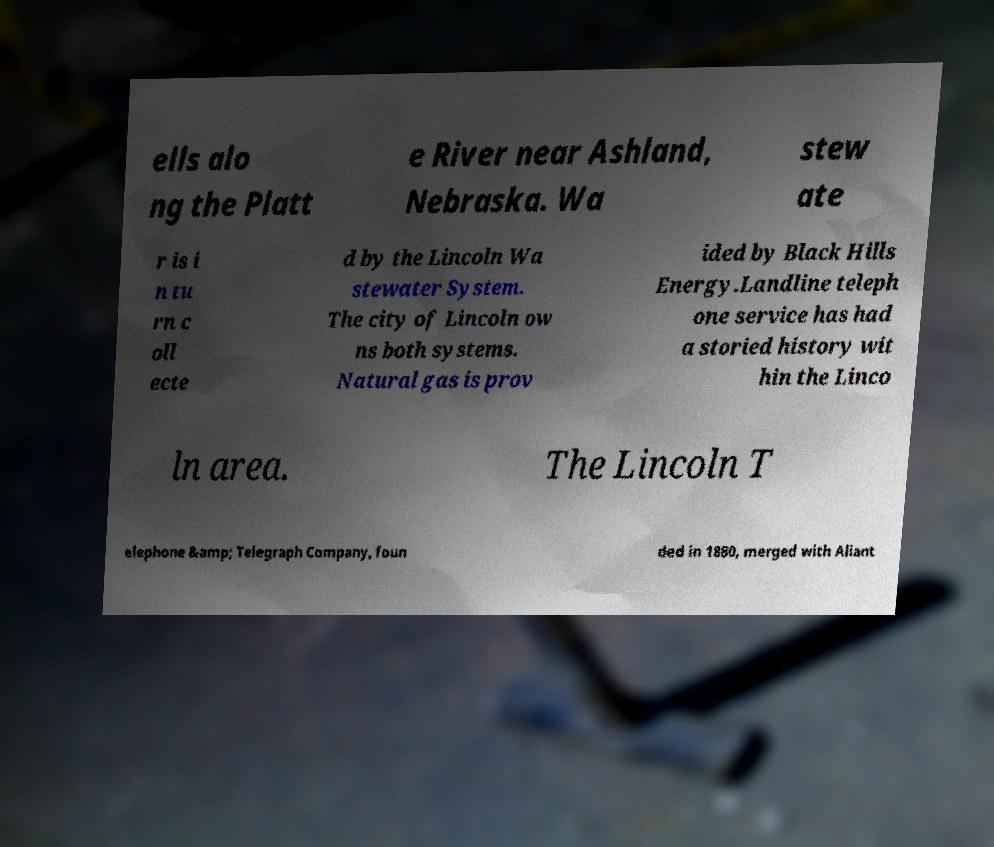Can you accurately transcribe the text from the provided image for me? ells alo ng the Platt e River near Ashland, Nebraska. Wa stew ate r is i n tu rn c oll ecte d by the Lincoln Wa stewater System. The city of Lincoln ow ns both systems. Natural gas is prov ided by Black Hills Energy.Landline teleph one service has had a storied history wit hin the Linco ln area. The Lincoln T elephone &amp; Telegraph Company, foun ded in 1880, merged with Aliant 